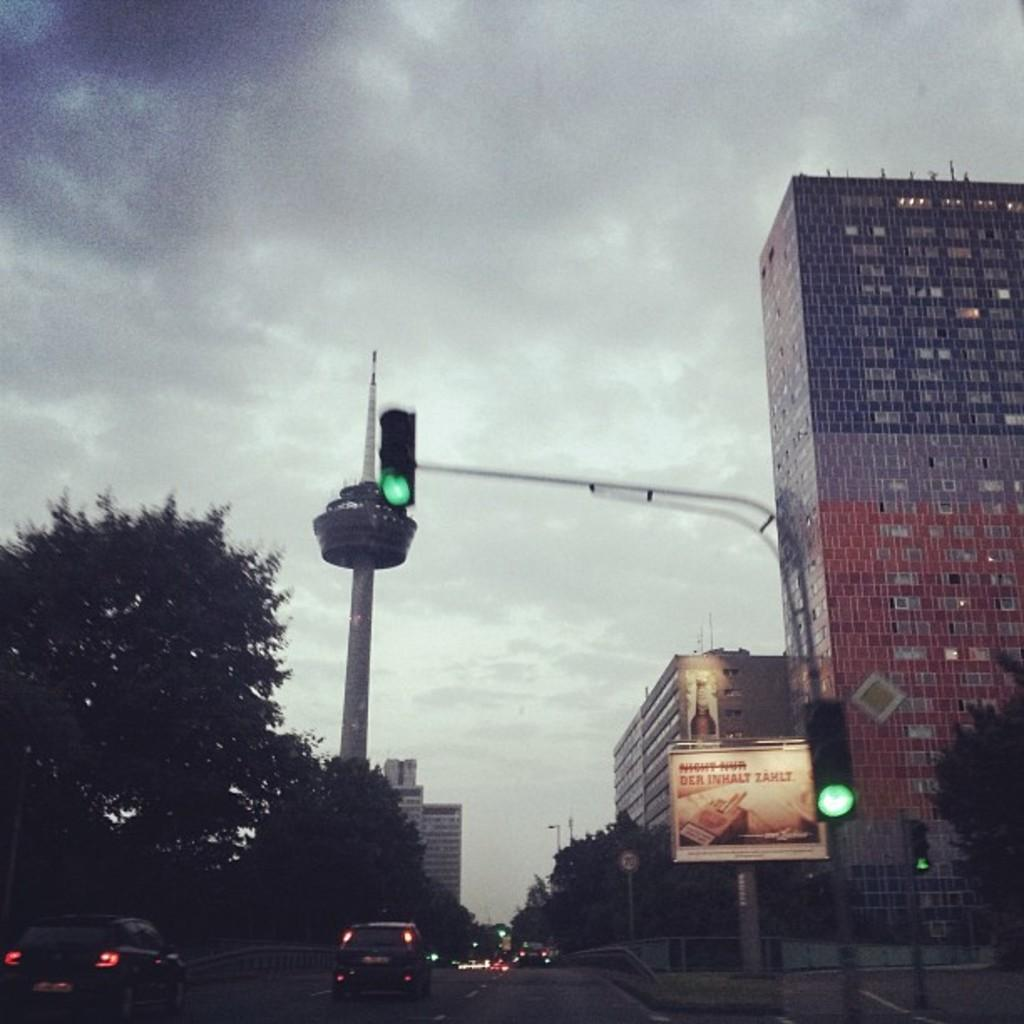What can be seen on the road in the image? There are vehicles on the road in the image. What type of vegetation is on the left side of the image? There are trees on the left side of the image. What type of structures are on the right side of the image? There are buildings on the right side of the image. What is visible in the background of the image? The sky is visible in the background of the image. Can you see a sack being carried by someone in the image? There is no sack or person carrying a sack present in the image. What type of carriage is visible in the image? There is no carriage present in the image. 